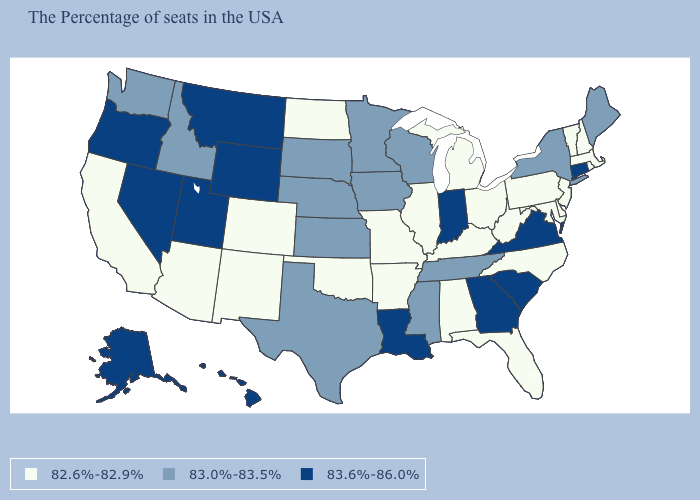Does Indiana have the lowest value in the MidWest?
Keep it brief. No. Which states have the highest value in the USA?
Quick response, please. Connecticut, Virginia, South Carolina, Georgia, Indiana, Louisiana, Wyoming, Utah, Montana, Nevada, Oregon, Alaska, Hawaii. Is the legend a continuous bar?
Give a very brief answer. No. Among the states that border New Mexico , which have the highest value?
Quick response, please. Utah. Is the legend a continuous bar?
Short answer required. No. What is the highest value in the MidWest ?
Be succinct. 83.6%-86.0%. What is the lowest value in the Northeast?
Answer briefly. 82.6%-82.9%. Name the states that have a value in the range 82.6%-82.9%?
Concise answer only. Massachusetts, Rhode Island, New Hampshire, Vermont, New Jersey, Delaware, Maryland, Pennsylvania, North Carolina, West Virginia, Ohio, Florida, Michigan, Kentucky, Alabama, Illinois, Missouri, Arkansas, Oklahoma, North Dakota, Colorado, New Mexico, Arizona, California. Which states have the highest value in the USA?
Give a very brief answer. Connecticut, Virginia, South Carolina, Georgia, Indiana, Louisiana, Wyoming, Utah, Montana, Nevada, Oregon, Alaska, Hawaii. Among the states that border New Mexico , which have the highest value?
Short answer required. Utah. Which states have the highest value in the USA?
Answer briefly. Connecticut, Virginia, South Carolina, Georgia, Indiana, Louisiana, Wyoming, Utah, Montana, Nevada, Oregon, Alaska, Hawaii. What is the value of Iowa?
Give a very brief answer. 83.0%-83.5%. Name the states that have a value in the range 83.6%-86.0%?
Concise answer only. Connecticut, Virginia, South Carolina, Georgia, Indiana, Louisiana, Wyoming, Utah, Montana, Nevada, Oregon, Alaska, Hawaii. Does the first symbol in the legend represent the smallest category?
Short answer required. Yes. What is the lowest value in the USA?
Answer briefly. 82.6%-82.9%. 